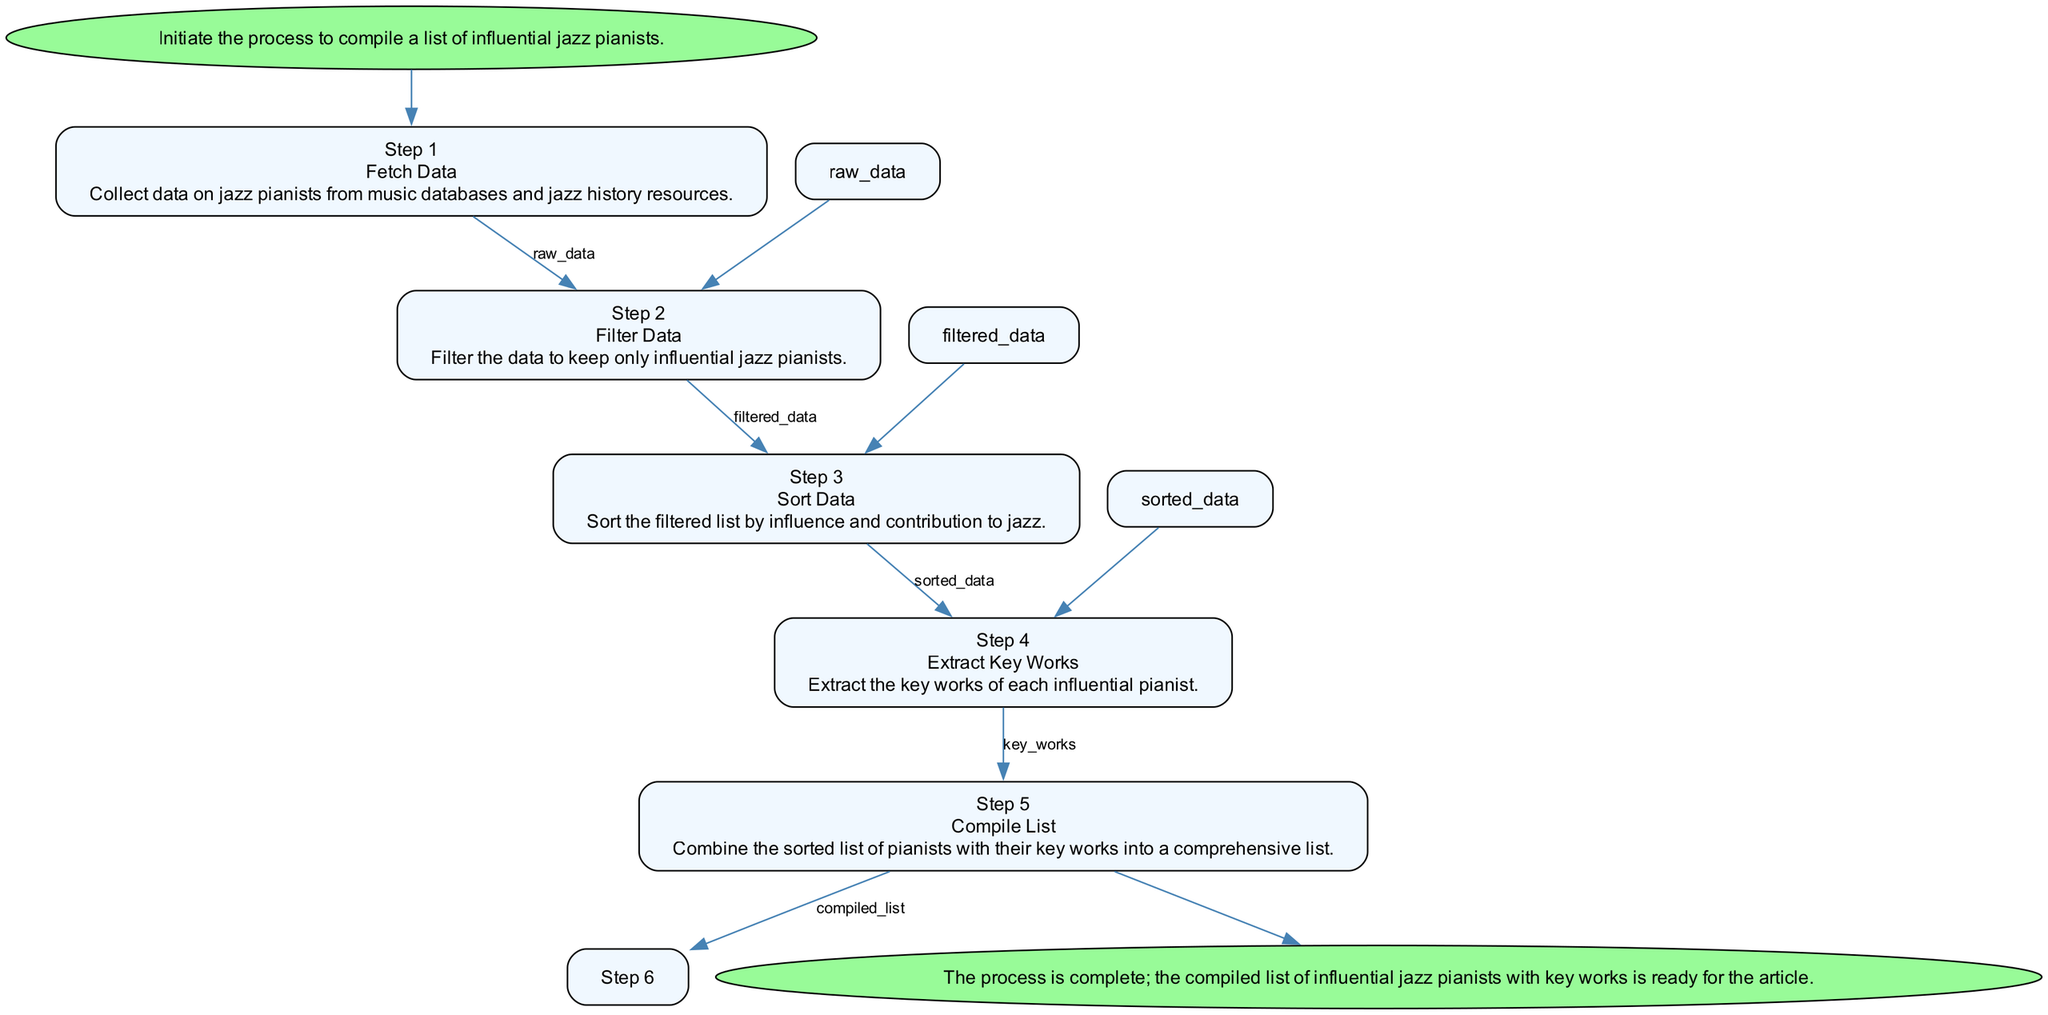What's the first action in the process? The first action in the process is indicated in the "Step 1" node, which states "Fetch Data." This is the action that initiates the compilation of the list.
Answer: Fetch Data How many steps are there in total? Counting the nodes labeled as steps in the flowchart ("Step 1" to "Step 5"), there are five steps in total, plus the "Start" and "End" nodes. Therefore, the total is seven.
Answer: 7 What is the output of "Step 2"? In "Step 2," which is the "Filter Data" step, the output is labeled as "filtered_data." This indicates the result of filtering the raw data in this step.
Answer: filtered_data What criteria are used to filter the data? The criteria for filtering the data, as noted in "Step 2," include "awards," "decades active," and "impact on genre." This shows what measures are considered to determine if a pianist is influential.
Answer: awards, decades active, impact on genre Which steps have an output? All steps except "Start" and "End" have an output. Specifically, "Step 1" has "raw_data," "Step 2" has "filtered_data," "Step 3" produces "sorted_data," and "Step 4" outputs "key_works." This indicates that processing occurs at these steps.
Answer: Step 1, Step 2, Step 3, Step 4 Which step extracts key works? "Step 4" is responsible for extracting key works. In this node, it explicitly states "Extract Key Works" as the action being carried out.
Answer: Step 4 What is the final output of the process? The final output of the flowchart is produced in "Step 5," labeled as "compiled_list." This shows what the end result of the entire process is intended to be.
Answer: compiled_list What is the last action taken in the process? The last action is found in "Step 5," which states "Compile List." This is the action performed just before reaching the "End" node.
Answer: Compile List How does the flow chart end? The flowchart ends with the node labeled "End," which concludes the process of compiling the list of influential jazz pianists and confirms the completion of the task.
Answer: End 